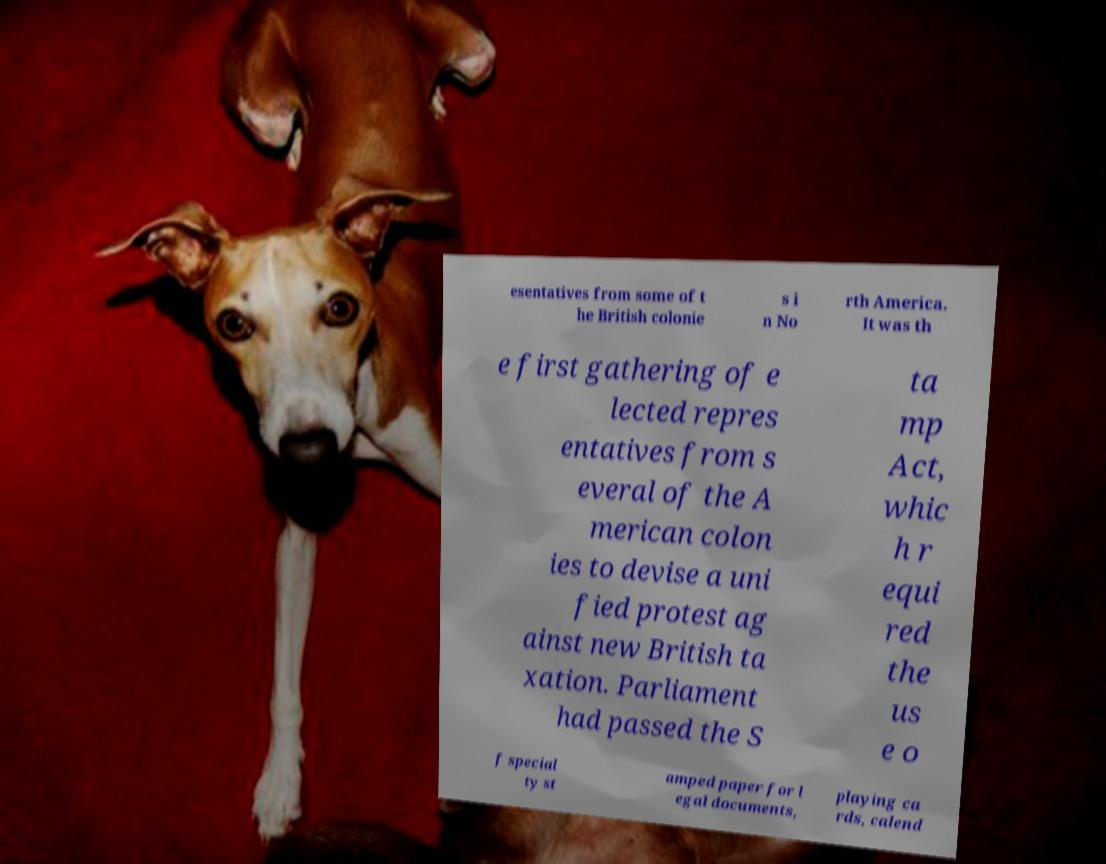Please identify and transcribe the text found in this image. esentatives from some of t he British colonie s i n No rth America. It was th e first gathering of e lected repres entatives from s everal of the A merican colon ies to devise a uni fied protest ag ainst new British ta xation. Parliament had passed the S ta mp Act, whic h r equi red the us e o f special ty st amped paper for l egal documents, playing ca rds, calend 